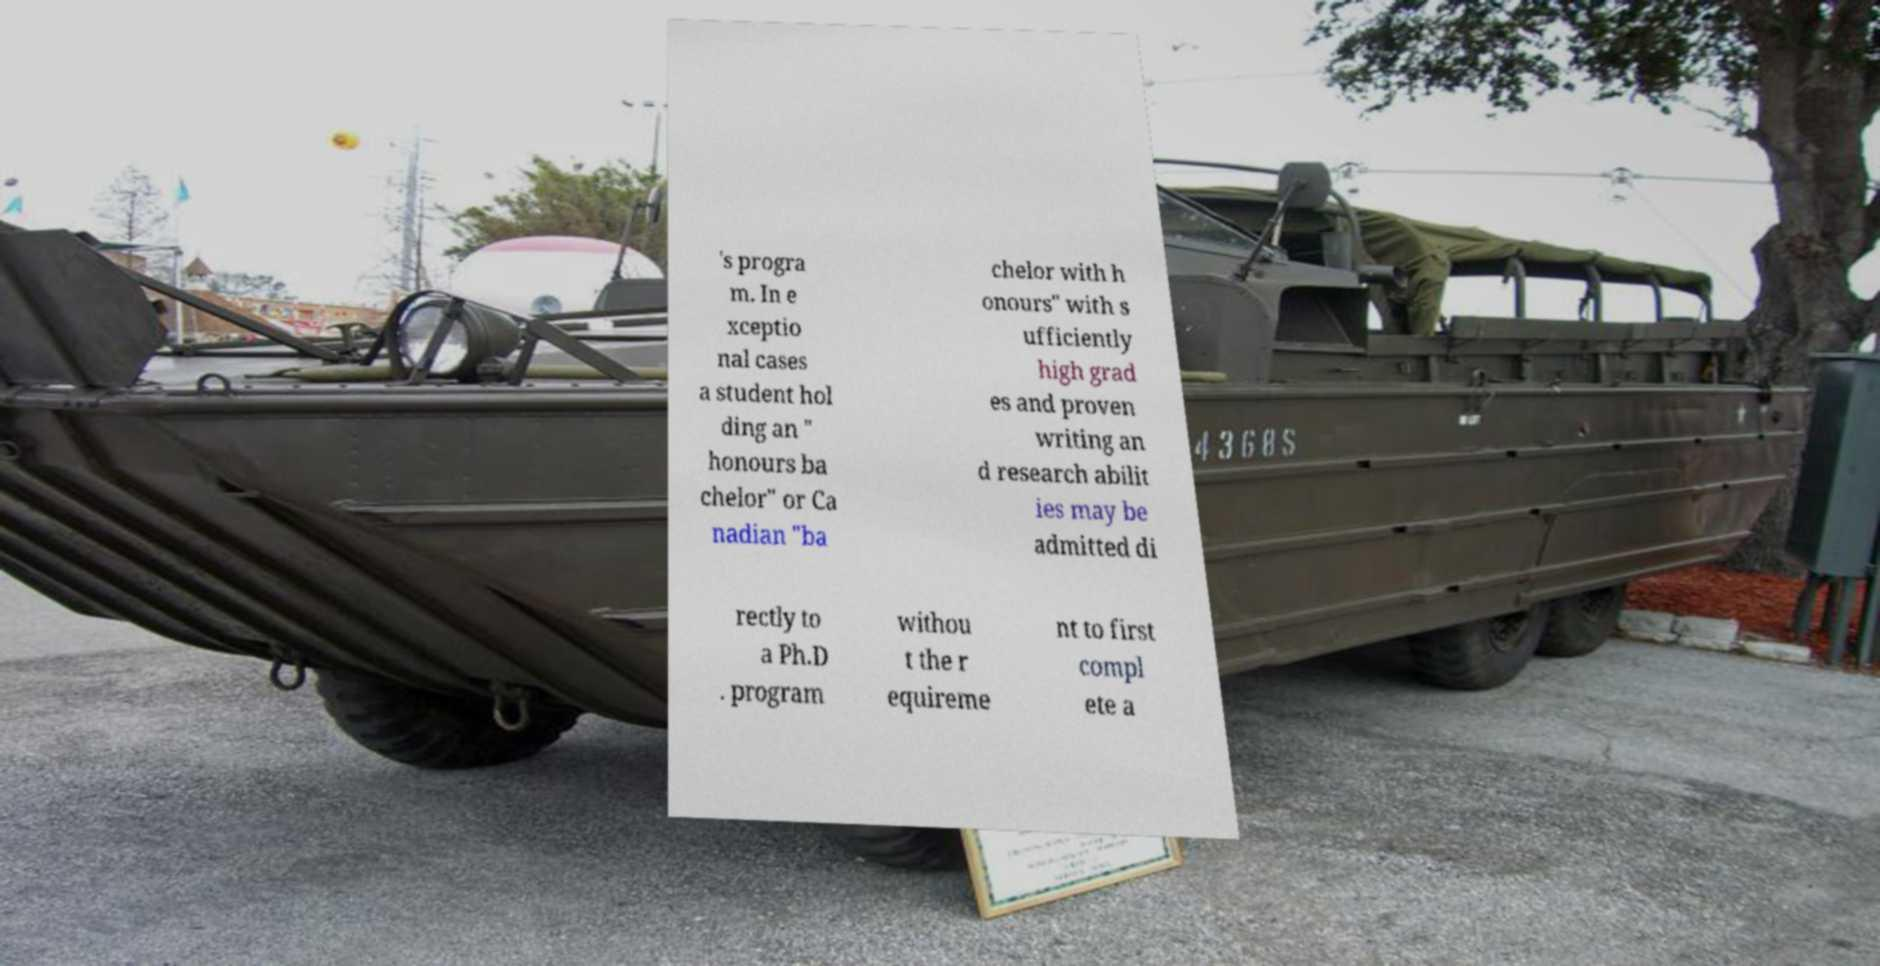I need the written content from this picture converted into text. Can you do that? 's progra m. In e xceptio nal cases a student hol ding an " honours ba chelor" or Ca nadian "ba chelor with h onours" with s ufficiently high grad es and proven writing an d research abilit ies may be admitted di rectly to a Ph.D . program withou t the r equireme nt to first compl ete a 